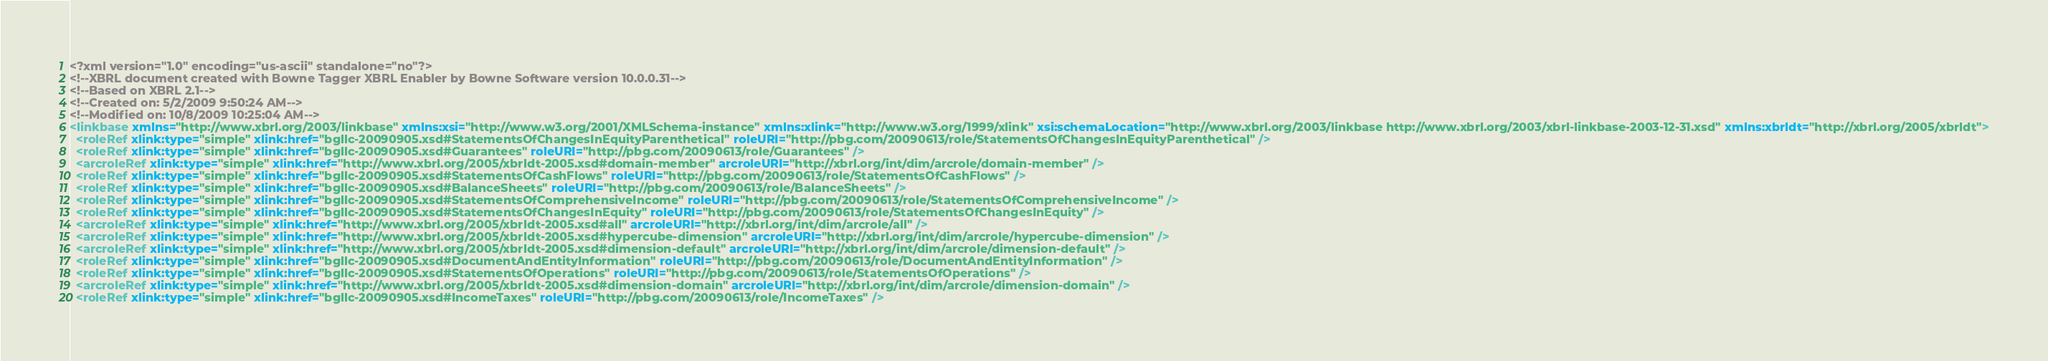Convert code to text. <code><loc_0><loc_0><loc_500><loc_500><_XML_><?xml version="1.0" encoding="us-ascii" standalone="no"?>
<!--XBRL document created with Bowne Tagger XBRL Enabler by Bowne Software version 10.0.0.31-->
<!--Based on XBRL 2.1-->
<!--Created on: 5/2/2009 9:50:24 AM-->
<!--Modified on: 10/8/2009 10:25:04 AM-->
<linkbase xmlns="http://www.xbrl.org/2003/linkbase" xmlns:xsi="http://www.w3.org/2001/XMLSchema-instance" xmlns:xlink="http://www.w3.org/1999/xlink" xsi:schemaLocation="http://www.xbrl.org/2003/linkbase http://www.xbrl.org/2003/xbrl-linkbase-2003-12-31.xsd" xmlns:xbrldt="http://xbrl.org/2005/xbrldt">
  <roleRef xlink:type="simple" xlink:href="bgllc-20090905.xsd#StatementsOfChangesInEquityParenthetical" roleURI="http://pbg.com/20090613/role/StatementsOfChangesInEquityParenthetical" />
  <roleRef xlink:type="simple" xlink:href="bgllc-20090905.xsd#Guarantees" roleURI="http://pbg.com/20090613/role/Guarantees" />
  <arcroleRef xlink:type="simple" xlink:href="http://www.xbrl.org/2005/xbrldt-2005.xsd#domain-member" arcroleURI="http://xbrl.org/int/dim/arcrole/domain-member" />
  <roleRef xlink:type="simple" xlink:href="bgllc-20090905.xsd#StatementsOfCashFlows" roleURI="http://pbg.com/20090613/role/StatementsOfCashFlows" />
  <roleRef xlink:type="simple" xlink:href="bgllc-20090905.xsd#BalanceSheets" roleURI="http://pbg.com/20090613/role/BalanceSheets" />
  <roleRef xlink:type="simple" xlink:href="bgllc-20090905.xsd#StatementsOfComprehensiveIncome" roleURI="http://pbg.com/20090613/role/StatementsOfComprehensiveIncome" />
  <roleRef xlink:type="simple" xlink:href="bgllc-20090905.xsd#StatementsOfChangesInEquity" roleURI="http://pbg.com/20090613/role/StatementsOfChangesInEquity" />
  <arcroleRef xlink:type="simple" xlink:href="http://www.xbrl.org/2005/xbrldt-2005.xsd#all" arcroleURI="http://xbrl.org/int/dim/arcrole/all" />
  <arcroleRef xlink:type="simple" xlink:href="http://www.xbrl.org/2005/xbrldt-2005.xsd#hypercube-dimension" arcroleURI="http://xbrl.org/int/dim/arcrole/hypercube-dimension" />
  <arcroleRef xlink:type="simple" xlink:href="http://www.xbrl.org/2005/xbrldt-2005.xsd#dimension-default" arcroleURI="http://xbrl.org/int/dim/arcrole/dimension-default" />
  <roleRef xlink:type="simple" xlink:href="bgllc-20090905.xsd#DocumentAndEntityInformation" roleURI="http://pbg.com/20090613/role/DocumentAndEntityInformation" />
  <roleRef xlink:type="simple" xlink:href="bgllc-20090905.xsd#StatementsOfOperations" roleURI="http://pbg.com/20090613/role/StatementsOfOperations" />
  <arcroleRef xlink:type="simple" xlink:href="http://www.xbrl.org/2005/xbrldt-2005.xsd#dimension-domain" arcroleURI="http://xbrl.org/int/dim/arcrole/dimension-domain" />
  <roleRef xlink:type="simple" xlink:href="bgllc-20090905.xsd#IncomeTaxes" roleURI="http://pbg.com/20090613/role/IncomeTaxes" /></code> 